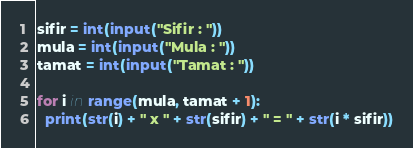Convert code to text. <code><loc_0><loc_0><loc_500><loc_500><_Python_>sifir = int(input("Sifir : "))
mula = int(input("Mula : "))
tamat = int(input("Tamat : "))

for i in range(mula, tamat + 1):
  print(str(i) + " x " + str(sifir) + " = " + str(i * sifir))
</code> 